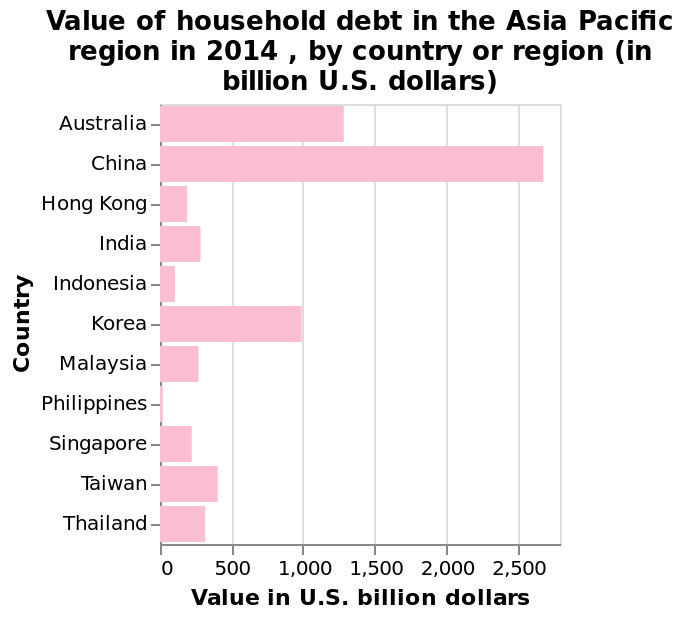<image>
How much household debt did Australia have in 2014?  Australia had 2,000 billion US dollars of household debt in 2014. What was the value of household debt in Korea in 2014? Korea had 1,000 billion US dollars of household debt in 2014. Did Korea have 100 billion US dollars of household debt in 2014? No.Korea had 1,000 billion US dollars of household debt in 2014. 